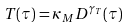<formula> <loc_0><loc_0><loc_500><loc_500>T ( \tau ) = \kappa _ { M } D ^ { \gamma _ { T } } ( \tau )</formula> 